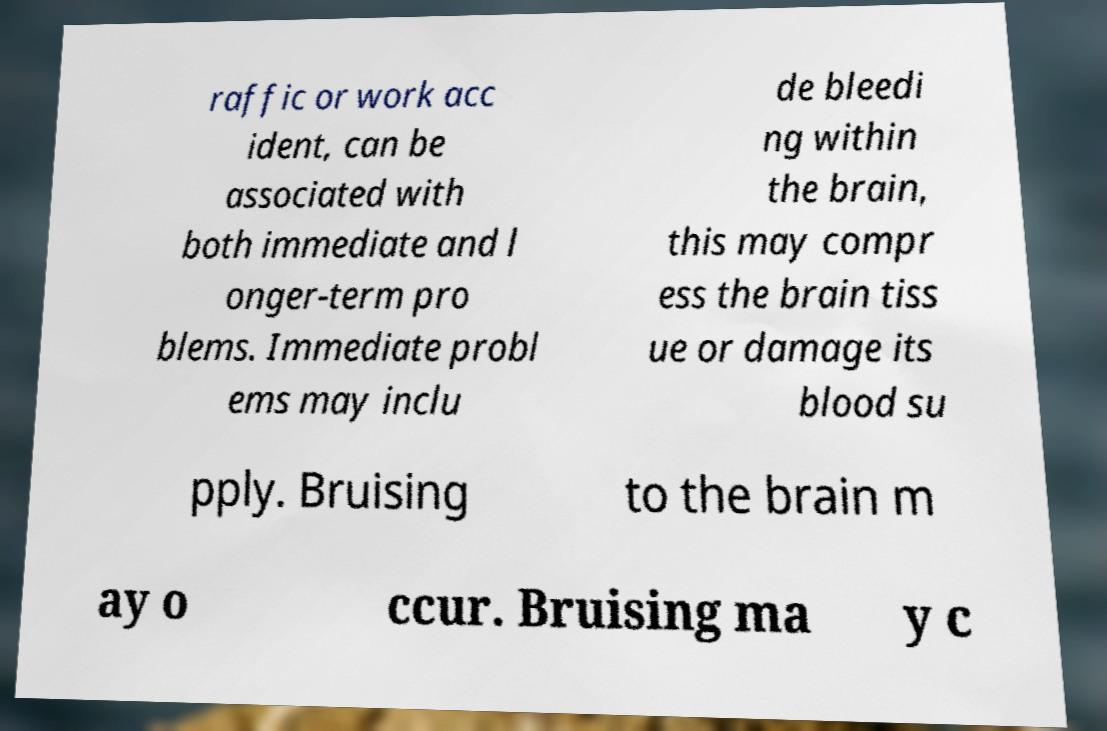Could you assist in decoding the text presented in this image and type it out clearly? raffic or work acc ident, can be associated with both immediate and l onger-term pro blems. Immediate probl ems may inclu de bleedi ng within the brain, this may compr ess the brain tiss ue or damage its blood su pply. Bruising to the brain m ay o ccur. Bruising ma y c 